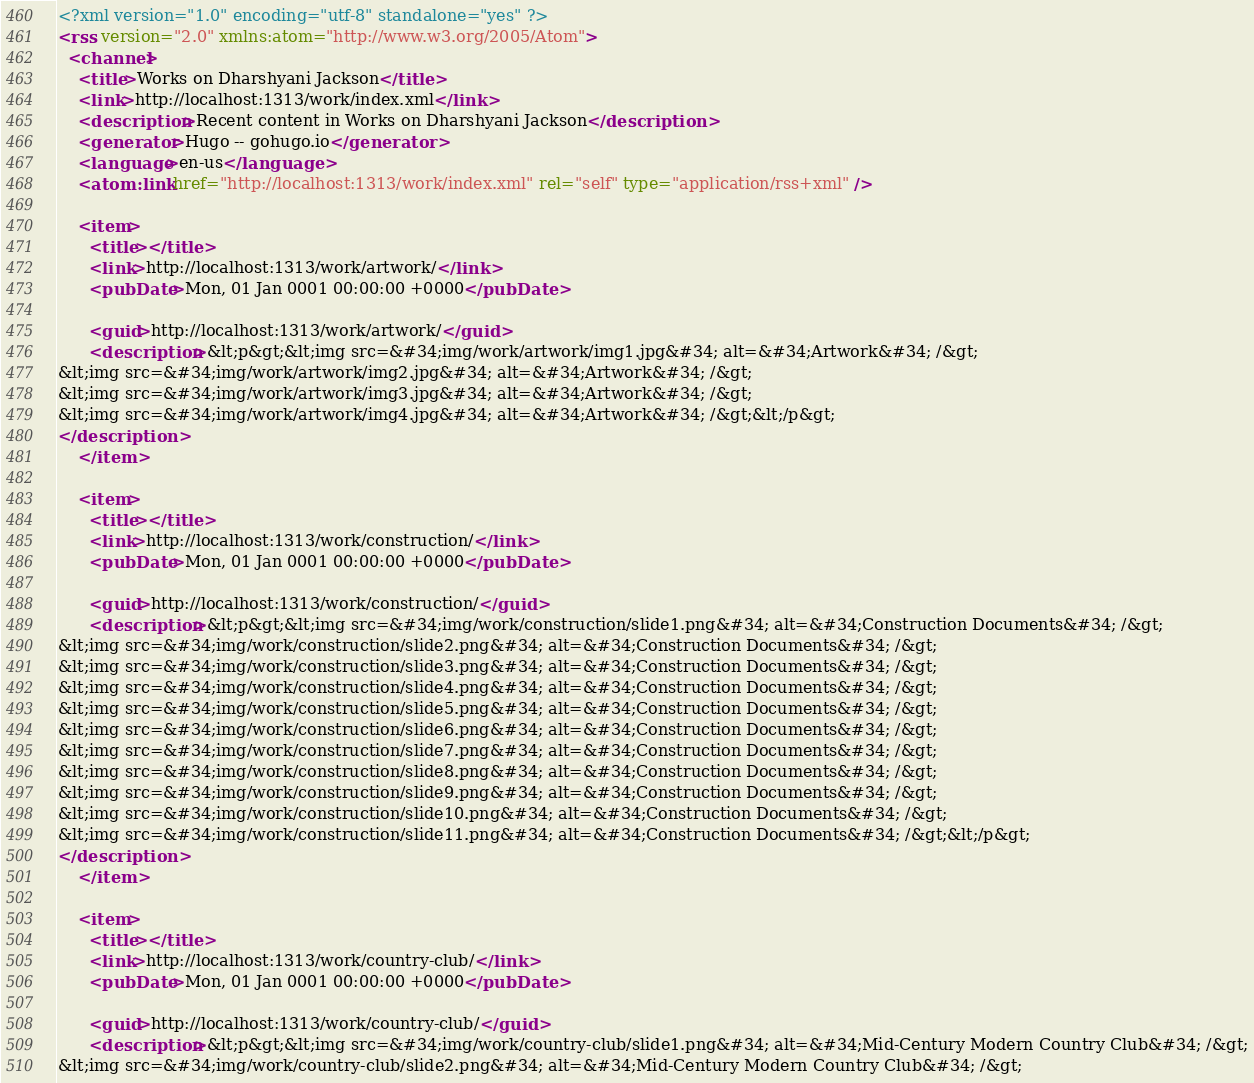<code> <loc_0><loc_0><loc_500><loc_500><_XML_><?xml version="1.0" encoding="utf-8" standalone="yes" ?>
<rss version="2.0" xmlns:atom="http://www.w3.org/2005/Atom">
  <channel>
    <title>Works on Dharshyani Jackson</title>
    <link>http://localhost:1313/work/index.xml</link>
    <description>Recent content in Works on Dharshyani Jackson</description>
    <generator>Hugo -- gohugo.io</generator>
    <language>en-us</language>
    <atom:link href="http://localhost:1313/work/index.xml" rel="self" type="application/rss+xml" />
    
    <item>
      <title></title>
      <link>http://localhost:1313/work/artwork/</link>
      <pubDate>Mon, 01 Jan 0001 00:00:00 +0000</pubDate>
      
      <guid>http://localhost:1313/work/artwork/</guid>
      <description>&lt;p&gt;&lt;img src=&#34;img/work/artwork/img1.jpg&#34; alt=&#34;Artwork&#34; /&gt;
&lt;img src=&#34;img/work/artwork/img2.jpg&#34; alt=&#34;Artwork&#34; /&gt;
&lt;img src=&#34;img/work/artwork/img3.jpg&#34; alt=&#34;Artwork&#34; /&gt;
&lt;img src=&#34;img/work/artwork/img4.jpg&#34; alt=&#34;Artwork&#34; /&gt;&lt;/p&gt;
</description>
    </item>
    
    <item>
      <title></title>
      <link>http://localhost:1313/work/construction/</link>
      <pubDate>Mon, 01 Jan 0001 00:00:00 +0000</pubDate>
      
      <guid>http://localhost:1313/work/construction/</guid>
      <description>&lt;p&gt;&lt;img src=&#34;img/work/construction/slide1.png&#34; alt=&#34;Construction Documents&#34; /&gt;
&lt;img src=&#34;img/work/construction/slide2.png&#34; alt=&#34;Construction Documents&#34; /&gt;
&lt;img src=&#34;img/work/construction/slide3.png&#34; alt=&#34;Construction Documents&#34; /&gt;
&lt;img src=&#34;img/work/construction/slide4.png&#34; alt=&#34;Construction Documents&#34; /&gt;
&lt;img src=&#34;img/work/construction/slide5.png&#34; alt=&#34;Construction Documents&#34; /&gt;
&lt;img src=&#34;img/work/construction/slide6.png&#34; alt=&#34;Construction Documents&#34; /&gt;
&lt;img src=&#34;img/work/construction/slide7.png&#34; alt=&#34;Construction Documents&#34; /&gt;
&lt;img src=&#34;img/work/construction/slide8.png&#34; alt=&#34;Construction Documents&#34; /&gt;
&lt;img src=&#34;img/work/construction/slide9.png&#34; alt=&#34;Construction Documents&#34; /&gt;
&lt;img src=&#34;img/work/construction/slide10.png&#34; alt=&#34;Construction Documents&#34; /&gt;
&lt;img src=&#34;img/work/construction/slide11.png&#34; alt=&#34;Construction Documents&#34; /&gt;&lt;/p&gt;
</description>
    </item>
    
    <item>
      <title></title>
      <link>http://localhost:1313/work/country-club/</link>
      <pubDate>Mon, 01 Jan 0001 00:00:00 +0000</pubDate>
      
      <guid>http://localhost:1313/work/country-club/</guid>
      <description>&lt;p&gt;&lt;img src=&#34;img/work/country-club/slide1.png&#34; alt=&#34;Mid-Century Modern Country Club&#34; /&gt;
&lt;img src=&#34;img/work/country-club/slide2.png&#34; alt=&#34;Mid-Century Modern Country Club&#34; /&gt;</code> 